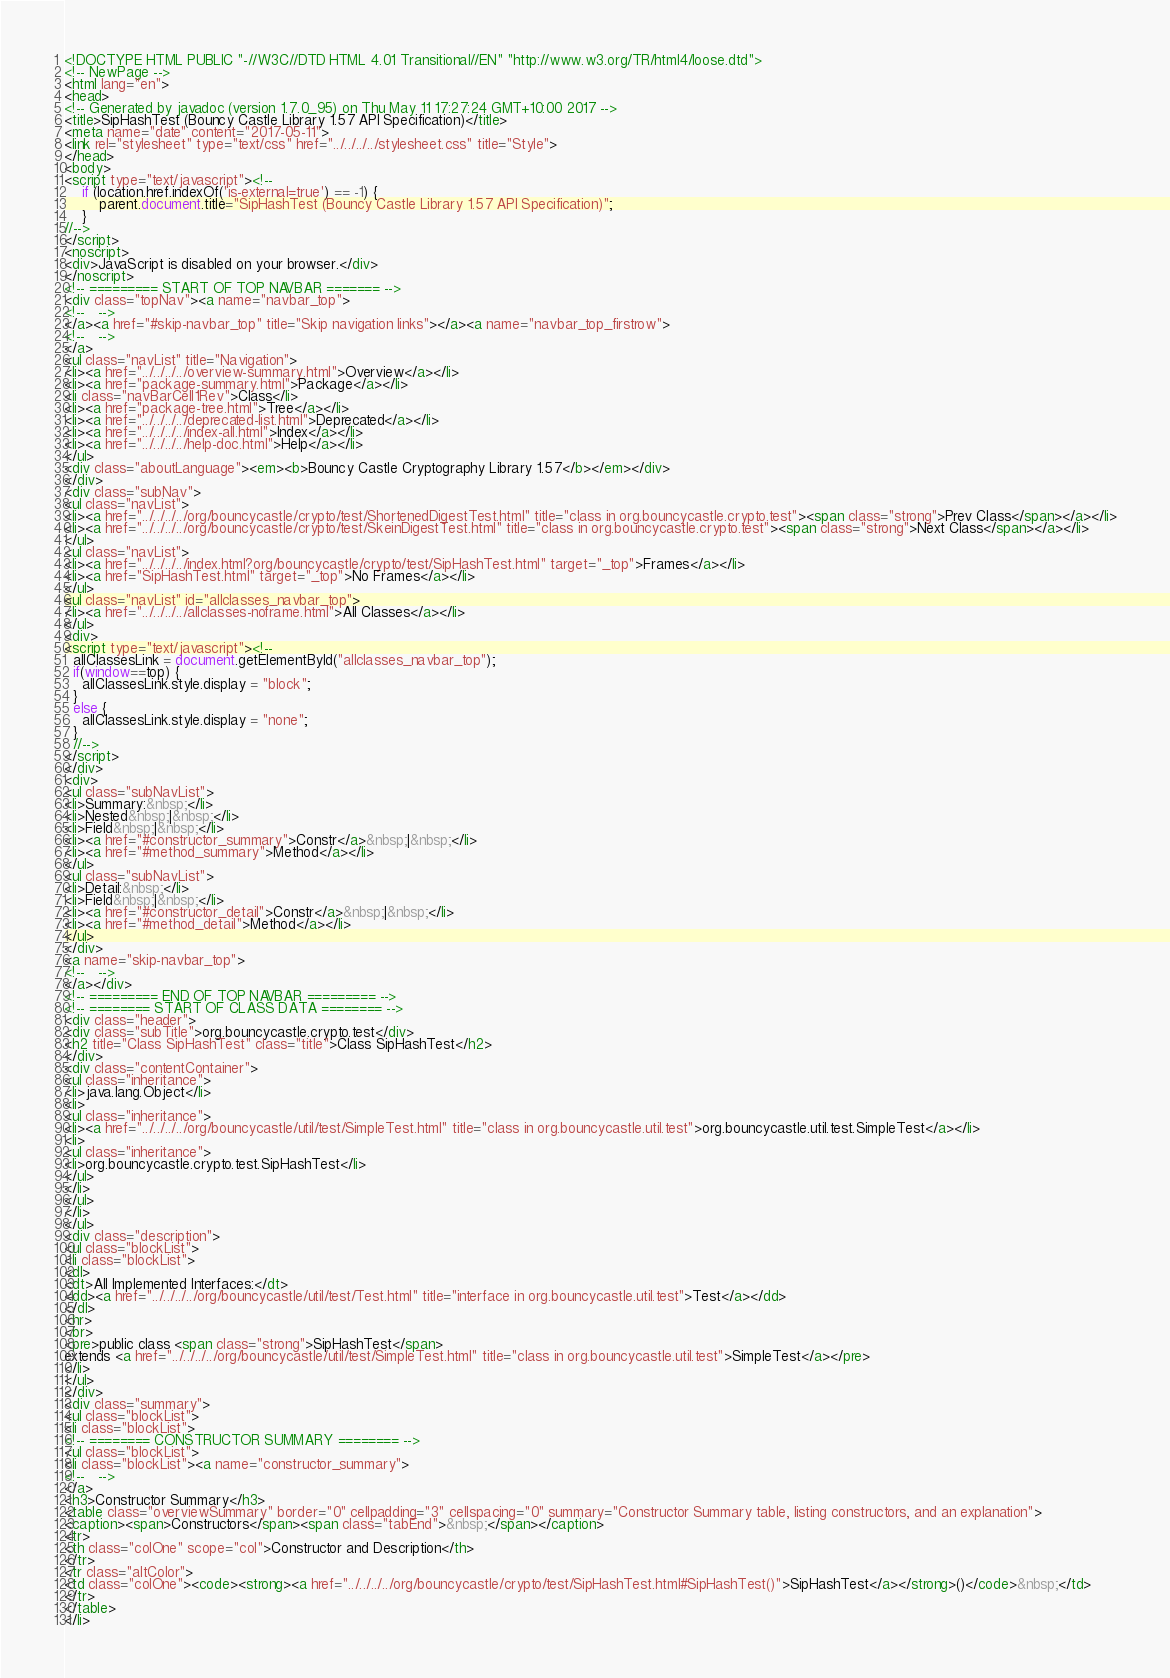<code> <loc_0><loc_0><loc_500><loc_500><_HTML_><!DOCTYPE HTML PUBLIC "-//W3C//DTD HTML 4.01 Transitional//EN" "http://www.w3.org/TR/html4/loose.dtd">
<!-- NewPage -->
<html lang="en">
<head>
<!-- Generated by javadoc (version 1.7.0_95) on Thu May 11 17:27:24 GMT+10:00 2017 -->
<title>SipHashTest (Bouncy Castle Library 1.57 API Specification)</title>
<meta name="date" content="2017-05-11">
<link rel="stylesheet" type="text/css" href="../../../../stylesheet.css" title="Style">
</head>
<body>
<script type="text/javascript"><!--
    if (location.href.indexOf('is-external=true') == -1) {
        parent.document.title="SipHashTest (Bouncy Castle Library 1.57 API Specification)";
    }
//-->
</script>
<noscript>
<div>JavaScript is disabled on your browser.</div>
</noscript>
<!-- ========= START OF TOP NAVBAR ======= -->
<div class="topNav"><a name="navbar_top">
<!--   -->
</a><a href="#skip-navbar_top" title="Skip navigation links"></a><a name="navbar_top_firstrow">
<!--   -->
</a>
<ul class="navList" title="Navigation">
<li><a href="../../../../overview-summary.html">Overview</a></li>
<li><a href="package-summary.html">Package</a></li>
<li class="navBarCell1Rev">Class</li>
<li><a href="package-tree.html">Tree</a></li>
<li><a href="../../../../deprecated-list.html">Deprecated</a></li>
<li><a href="../../../../index-all.html">Index</a></li>
<li><a href="../../../../help-doc.html">Help</a></li>
</ul>
<div class="aboutLanguage"><em><b>Bouncy Castle Cryptography Library 1.57</b></em></div>
</div>
<div class="subNav">
<ul class="navList">
<li><a href="../../../../org/bouncycastle/crypto/test/ShortenedDigestTest.html" title="class in org.bouncycastle.crypto.test"><span class="strong">Prev Class</span></a></li>
<li><a href="../../../../org/bouncycastle/crypto/test/SkeinDigestTest.html" title="class in org.bouncycastle.crypto.test"><span class="strong">Next Class</span></a></li>
</ul>
<ul class="navList">
<li><a href="../../../../index.html?org/bouncycastle/crypto/test/SipHashTest.html" target="_top">Frames</a></li>
<li><a href="SipHashTest.html" target="_top">No Frames</a></li>
</ul>
<ul class="navList" id="allclasses_navbar_top">
<li><a href="../../../../allclasses-noframe.html">All Classes</a></li>
</ul>
<div>
<script type="text/javascript"><!--
  allClassesLink = document.getElementById("allclasses_navbar_top");
  if(window==top) {
    allClassesLink.style.display = "block";
  }
  else {
    allClassesLink.style.display = "none";
  }
  //-->
</script>
</div>
<div>
<ul class="subNavList">
<li>Summary:&nbsp;</li>
<li>Nested&nbsp;|&nbsp;</li>
<li>Field&nbsp;|&nbsp;</li>
<li><a href="#constructor_summary">Constr</a>&nbsp;|&nbsp;</li>
<li><a href="#method_summary">Method</a></li>
</ul>
<ul class="subNavList">
<li>Detail:&nbsp;</li>
<li>Field&nbsp;|&nbsp;</li>
<li><a href="#constructor_detail">Constr</a>&nbsp;|&nbsp;</li>
<li><a href="#method_detail">Method</a></li>
</ul>
</div>
<a name="skip-navbar_top">
<!--   -->
</a></div>
<!-- ========= END OF TOP NAVBAR ========= -->
<!-- ======== START OF CLASS DATA ======== -->
<div class="header">
<div class="subTitle">org.bouncycastle.crypto.test</div>
<h2 title="Class SipHashTest" class="title">Class SipHashTest</h2>
</div>
<div class="contentContainer">
<ul class="inheritance">
<li>java.lang.Object</li>
<li>
<ul class="inheritance">
<li><a href="../../../../org/bouncycastle/util/test/SimpleTest.html" title="class in org.bouncycastle.util.test">org.bouncycastle.util.test.SimpleTest</a></li>
<li>
<ul class="inheritance">
<li>org.bouncycastle.crypto.test.SipHashTest</li>
</ul>
</li>
</ul>
</li>
</ul>
<div class="description">
<ul class="blockList">
<li class="blockList">
<dl>
<dt>All Implemented Interfaces:</dt>
<dd><a href="../../../../org/bouncycastle/util/test/Test.html" title="interface in org.bouncycastle.util.test">Test</a></dd>
</dl>
<hr>
<br>
<pre>public class <span class="strong">SipHashTest</span>
extends <a href="../../../../org/bouncycastle/util/test/SimpleTest.html" title="class in org.bouncycastle.util.test">SimpleTest</a></pre>
</li>
</ul>
</div>
<div class="summary">
<ul class="blockList">
<li class="blockList">
<!-- ======== CONSTRUCTOR SUMMARY ======== -->
<ul class="blockList">
<li class="blockList"><a name="constructor_summary">
<!--   -->
</a>
<h3>Constructor Summary</h3>
<table class="overviewSummary" border="0" cellpadding="3" cellspacing="0" summary="Constructor Summary table, listing constructors, and an explanation">
<caption><span>Constructors</span><span class="tabEnd">&nbsp;</span></caption>
<tr>
<th class="colOne" scope="col">Constructor and Description</th>
</tr>
<tr class="altColor">
<td class="colOne"><code><strong><a href="../../../../org/bouncycastle/crypto/test/SipHashTest.html#SipHashTest()">SipHashTest</a></strong>()</code>&nbsp;</td>
</tr>
</table>
</li></code> 